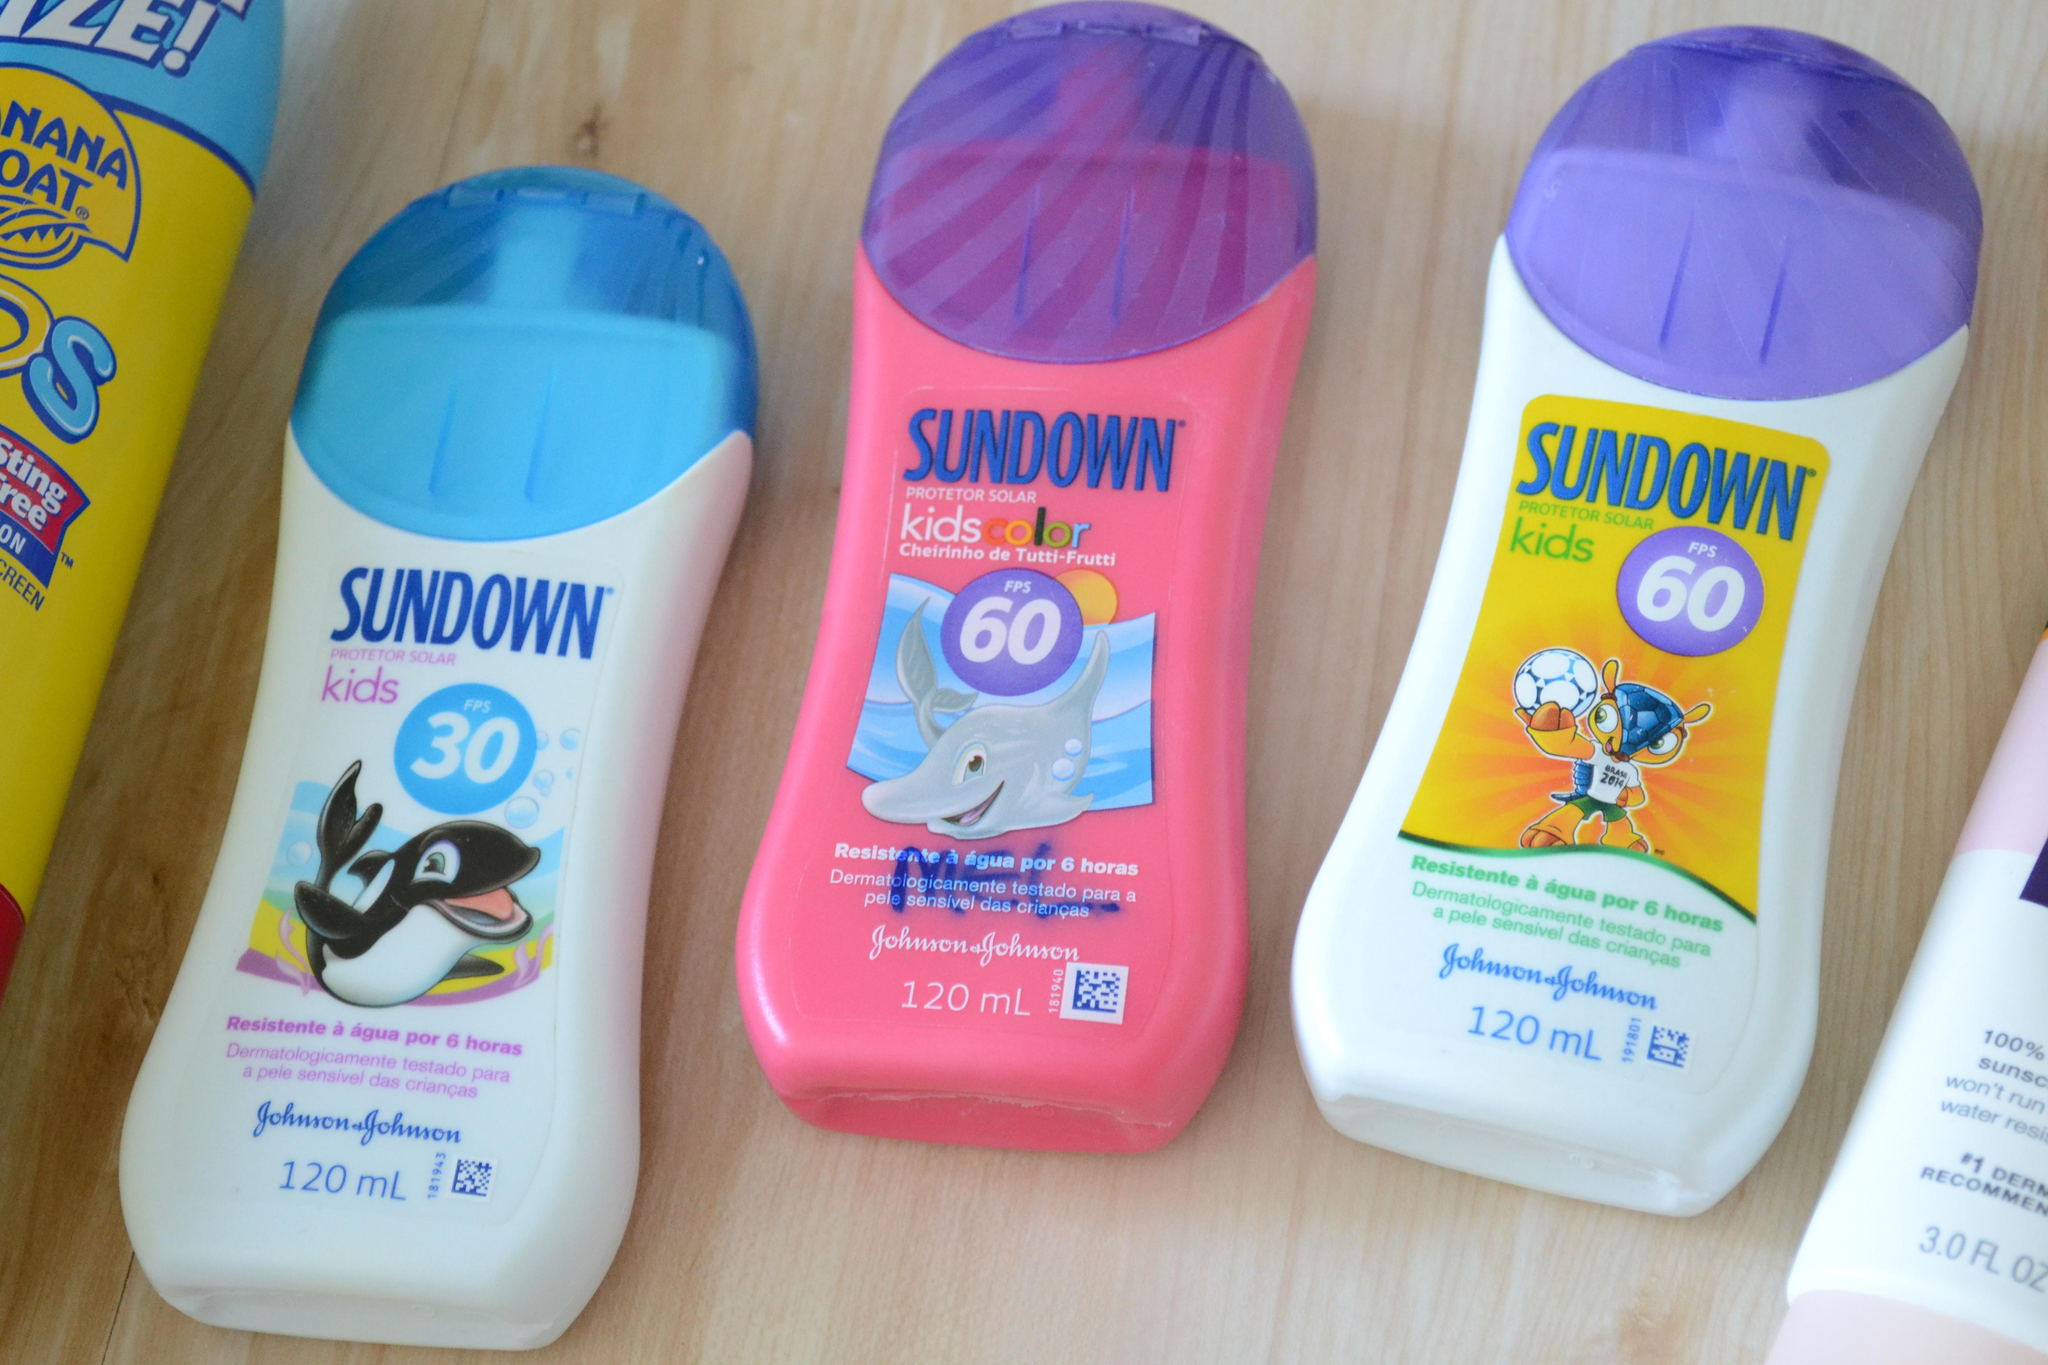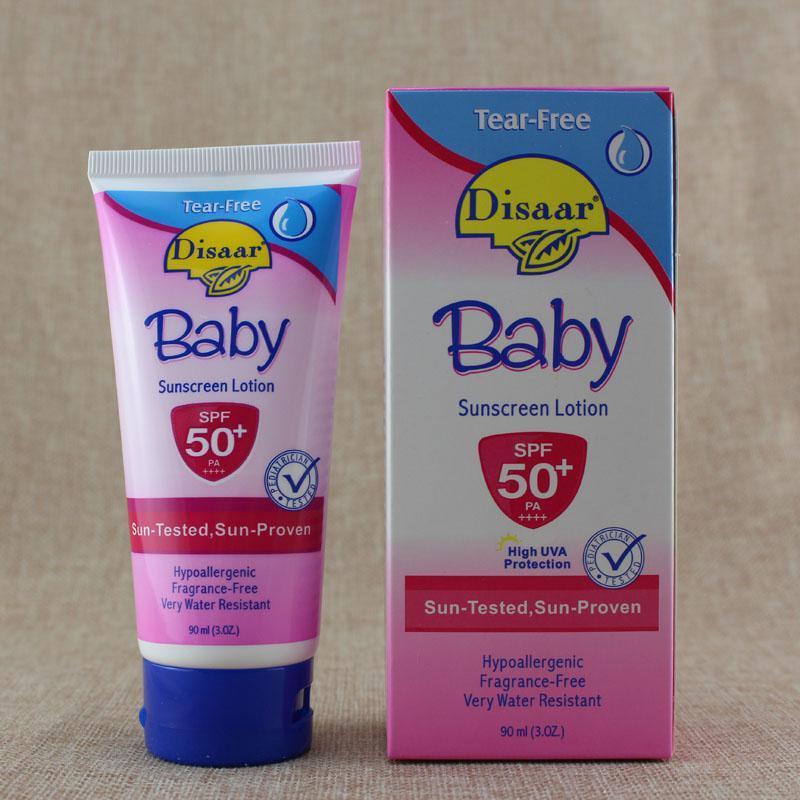The first image is the image on the left, the second image is the image on the right. For the images shown, is this caption "At least ten lotion-type products are shown in total." true? Answer yes or no. No. The first image is the image on the left, the second image is the image on the right. For the images shown, is this caption "The right image shows just two skincare items side-by-side." true? Answer yes or no. Yes. 